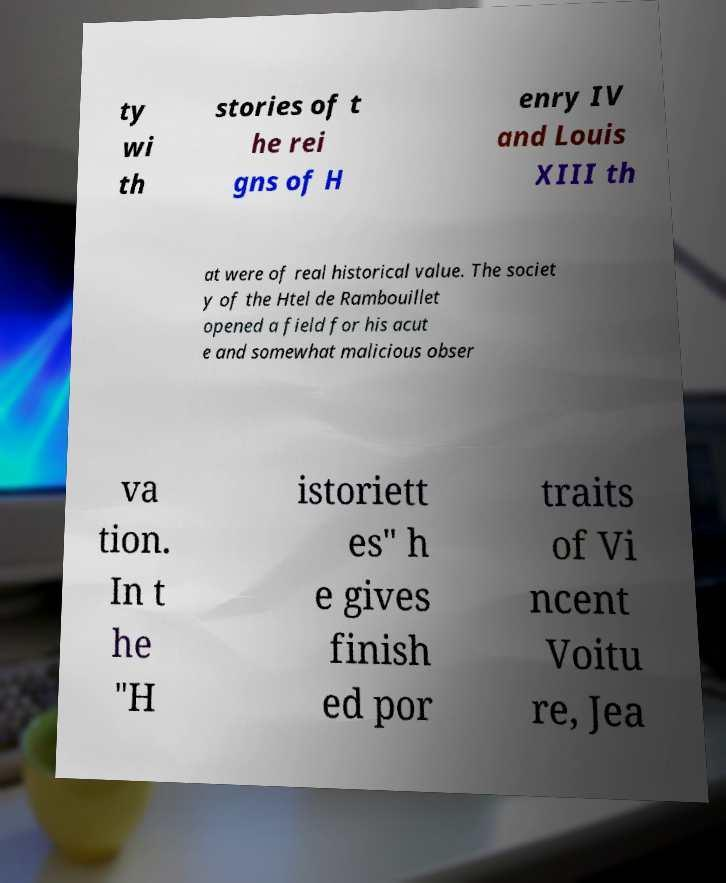What messages or text are displayed in this image? I need them in a readable, typed format. ty wi th stories of t he rei gns of H enry IV and Louis XIII th at were of real historical value. The societ y of the Htel de Rambouillet opened a field for his acut e and somewhat malicious obser va tion. In t he "H istoriett es" h e gives finish ed por traits of Vi ncent Voitu re, Jea 